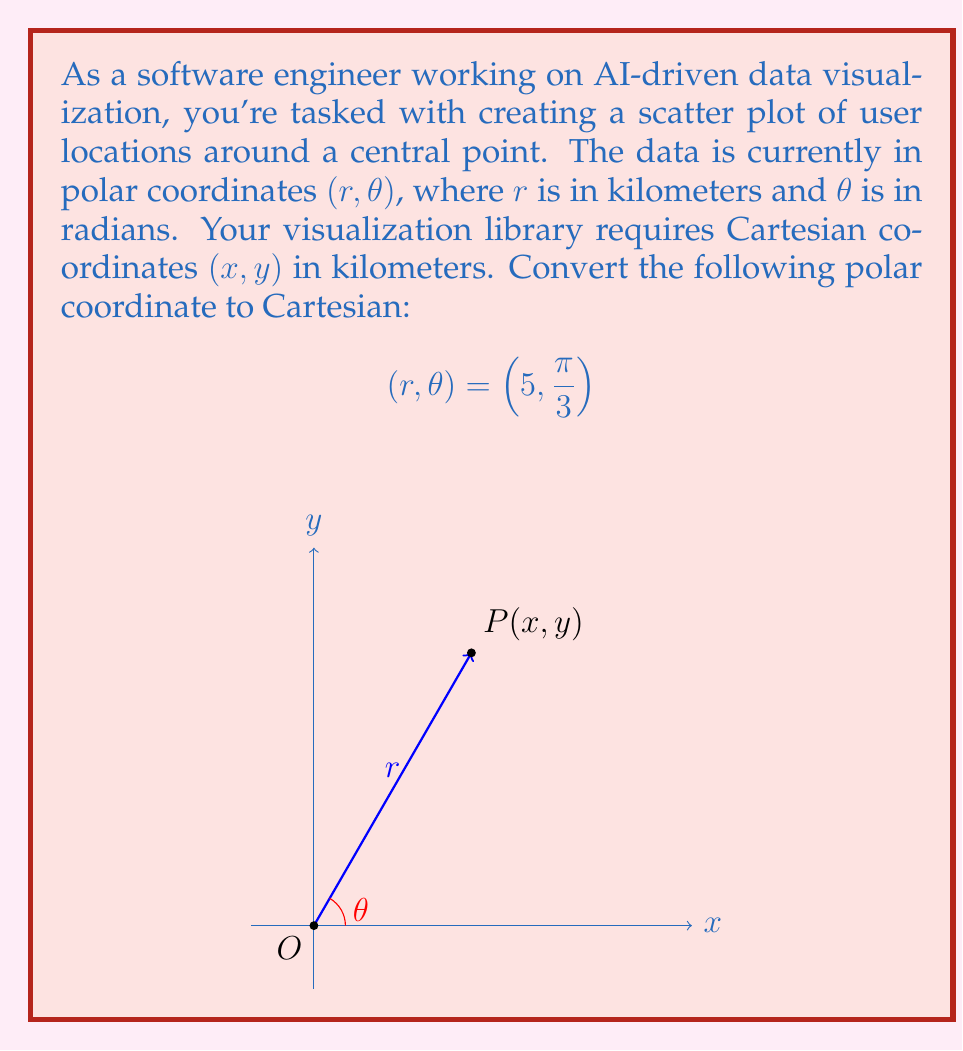Can you answer this question? To convert from polar coordinates (r, θ) to Cartesian coordinates (x, y), we use the following formulas:

1) $x = r \cos(\theta)$
2) $y = r \sin(\theta)$

Given:
$r = 5$ km
$\theta = \frac{\pi}{3}$ radians

Step 1: Calculate x
$$x = r \cos(\theta) = 5 \cos(\frac{\pi}{3})$$

$\cos(\frac{\pi}{3}) = \frac{1}{2}$, so:

$$x = 5 \cdot \frac{1}{2} = 2.5$$ km

Step 2: Calculate y
$$y = r \sin(\theta) = 5 \sin(\frac{\pi}{3})$$

$\sin(\frac{\pi}{3}) = \frac{\sqrt{3}}{2}$, so:

$$y = 5 \cdot \frac{\sqrt{3}}{2} = \frac{5\sqrt{3}}{2}$$ km

Therefore, the Cartesian coordinates are $(2.5, \frac{5\sqrt{3}}{2})$ km.
Answer: $(2.5, \frac{5\sqrt{3}}{2})$ km 